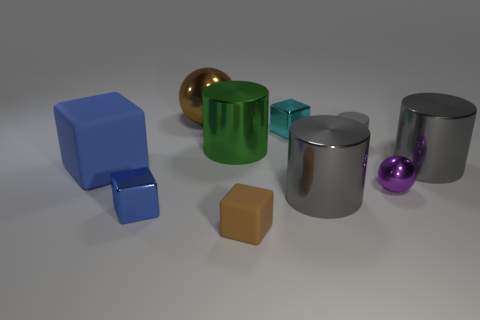Subtract all cyan blocks. How many gray cylinders are left? 3 Subtract all cylinders. How many objects are left? 6 Add 1 large purple objects. How many large purple objects exist? 1 Subtract 2 blue blocks. How many objects are left? 8 Subtract all cyan shiny objects. Subtract all brown metal balls. How many objects are left? 8 Add 5 spheres. How many spheres are left? 7 